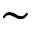<formula> <loc_0><loc_0><loc_500><loc_500>\sim</formula> 